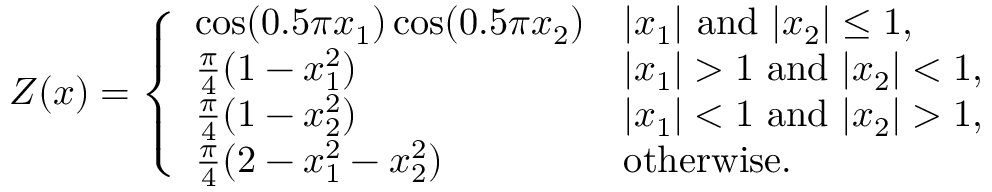Convert formula to latex. <formula><loc_0><loc_0><loc_500><loc_500>Z ( x ) = \left \{ \begin{array} { l l } { \cos ( 0 . 5 \pi x _ { 1 } ) \cos ( 0 . 5 \pi x _ { 2 } ) } & { | x _ { 1 } | a n d | x _ { 2 } | \leq 1 , } \\ { \frac { \pi } { 4 } ( 1 - x _ { 1 } ^ { 2 } ) } & { | x _ { 1 } | > 1 a n d | x _ { 2 } | < 1 , } \\ { \frac { \pi } { 4 } ( 1 - x _ { 2 } ^ { 2 } ) } & { | x _ { 1 } | < 1 a n d | x _ { 2 } | > 1 , } \\ { \frac { \pi } { 4 } ( 2 - x _ { 1 } ^ { 2 } - x _ { 2 } ^ { 2 } ) } & { o t h e r w i s e . } \end{array}</formula> 